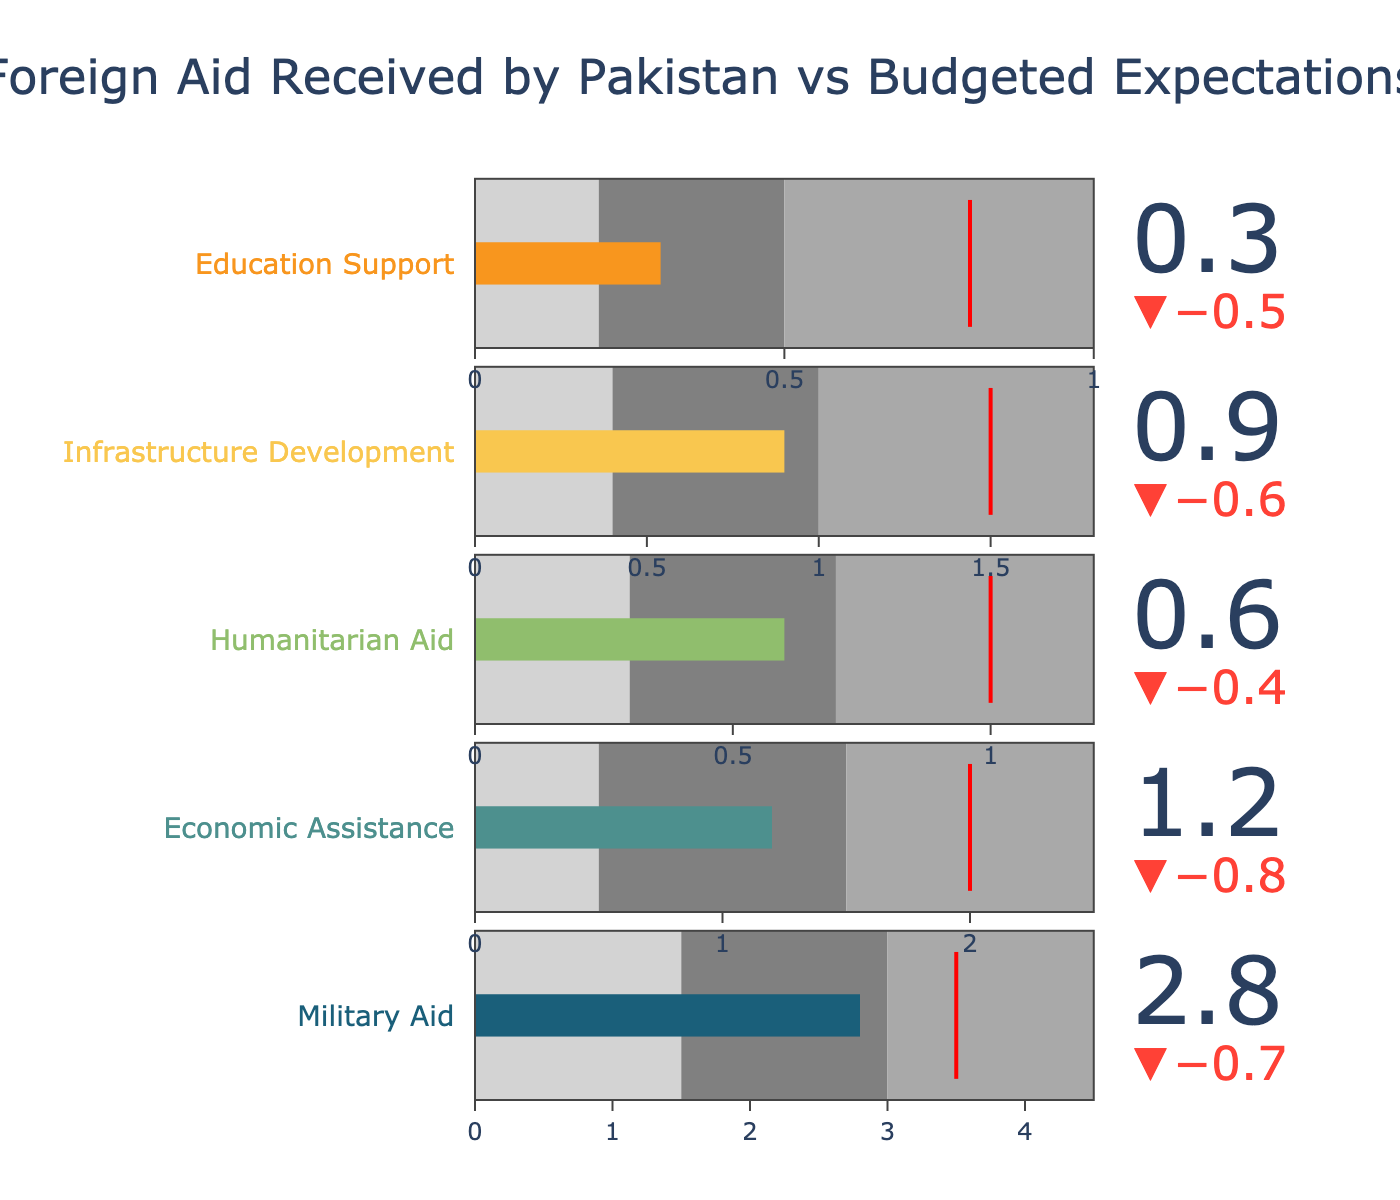What is the title of the figure? The title can be found at the top of the figure and typically gives an overview of what the chart is depicting. In this case, it states the main focus is comparing foreign aid received by Pakistan to budgeted expectations.
Answer: Foreign Aid Received by Pakistan vs Budgeted Expectations How many categories of aid are represented in the figure? By counting the number of distinct categories listed on the y-axis or labels, you can determine the number of different aids mentioned in the bullet chart.
Answer: 5 What is the value of military aid received by Pakistan? The value of military aid can be observed directly from the bullet that represents "Military Aid" in the chart.
Answer: 2.8 Which category of aid received the least amount compared to its target? By comparing the actual and target values for each category of aid, you can determine which category had the smallest proportion of aid received relative to its target.
Answer: Education Support What is the difference between the target and actual values for economic assistance? To find the difference, subtract the actual value of economic assistance from its target value (2.0 - 1.2).
Answer: 0.8 In which range does the actual value of humanitarian aid fall? Look at the specific range segments in the bullet for "Humanitarian Aid" and see where the actual value of 0.6 fits among the predefined ranges (0.3-1.2).
Answer: Between 0.3 and 0.7 How does the actual value of infrastructure development aid compare to its target? To compare, note that the target value is 1.5 and the actual value is 0.9. Since 0.9 is less than 1.5, it is below the target.
Answer: Below target Which aid category has the highest target value? By comparing the target values across all categories, you can see which one has the highest target to reach.
Answer: Military Aid What is the average target value of all the aid categories? To calculate the average, sum up all the target values (3.5 + 2.0 + 1.0 + 1.5 + 0.8 = 8.8) and divide by the number of categories (5). So, 8.8 / 5.
Answer: 1.76 